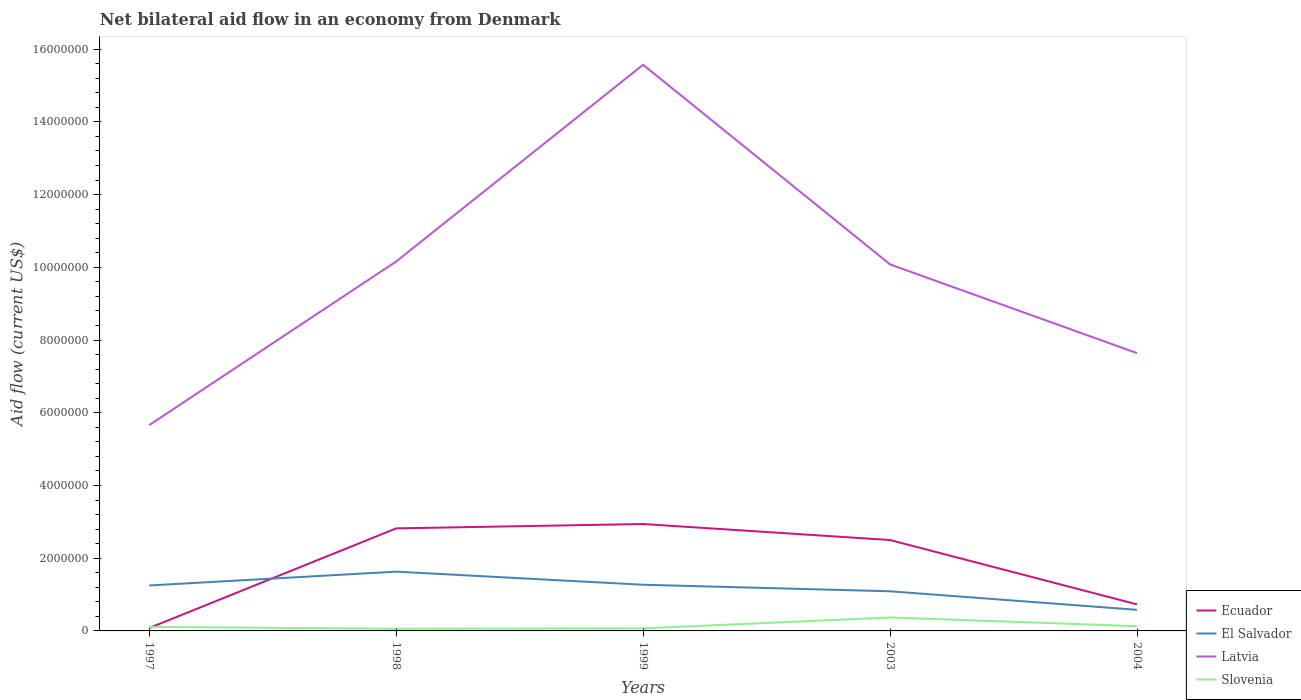Does the line corresponding to Ecuador intersect with the line corresponding to Latvia?
Keep it short and to the point. No. Is the number of lines equal to the number of legend labels?
Your answer should be very brief. Yes. Across all years, what is the maximum net bilateral aid flow in El Salvador?
Ensure brevity in your answer.  5.80e+05. In which year was the net bilateral aid flow in Latvia maximum?
Make the answer very short. 1997. What is the total net bilateral aid flow in Ecuador in the graph?
Give a very brief answer. -6.50e+05. What is the difference between the highest and the second highest net bilateral aid flow in Slovenia?
Your answer should be very brief. 3.10e+05. What is the difference between the highest and the lowest net bilateral aid flow in El Salvador?
Offer a very short reply. 3. Is the net bilateral aid flow in Latvia strictly greater than the net bilateral aid flow in Slovenia over the years?
Ensure brevity in your answer.  No. How many lines are there?
Offer a very short reply. 4. Does the graph contain any zero values?
Give a very brief answer. No. Does the graph contain grids?
Your answer should be compact. No. What is the title of the graph?
Your answer should be very brief. Net bilateral aid flow in an economy from Denmark. Does "Sao Tome and Principe" appear as one of the legend labels in the graph?
Your answer should be compact. No. What is the Aid flow (current US$) in El Salvador in 1997?
Provide a succinct answer. 1.25e+06. What is the Aid flow (current US$) of Latvia in 1997?
Ensure brevity in your answer.  5.66e+06. What is the Aid flow (current US$) in Slovenia in 1997?
Offer a very short reply. 1.10e+05. What is the Aid flow (current US$) of Ecuador in 1998?
Keep it short and to the point. 2.82e+06. What is the Aid flow (current US$) of El Salvador in 1998?
Keep it short and to the point. 1.63e+06. What is the Aid flow (current US$) in Latvia in 1998?
Keep it short and to the point. 1.02e+07. What is the Aid flow (current US$) of Ecuador in 1999?
Give a very brief answer. 2.94e+06. What is the Aid flow (current US$) of El Salvador in 1999?
Give a very brief answer. 1.27e+06. What is the Aid flow (current US$) in Latvia in 1999?
Make the answer very short. 1.56e+07. What is the Aid flow (current US$) of Slovenia in 1999?
Your response must be concise. 7.00e+04. What is the Aid flow (current US$) of Ecuador in 2003?
Offer a terse response. 2.50e+06. What is the Aid flow (current US$) of El Salvador in 2003?
Your response must be concise. 1.09e+06. What is the Aid flow (current US$) in Latvia in 2003?
Make the answer very short. 1.01e+07. What is the Aid flow (current US$) in Ecuador in 2004?
Your answer should be compact. 7.30e+05. What is the Aid flow (current US$) of El Salvador in 2004?
Provide a succinct answer. 5.80e+05. What is the Aid flow (current US$) in Latvia in 2004?
Give a very brief answer. 7.64e+06. What is the Aid flow (current US$) of Slovenia in 2004?
Offer a terse response. 1.30e+05. Across all years, what is the maximum Aid flow (current US$) in Ecuador?
Offer a very short reply. 2.94e+06. Across all years, what is the maximum Aid flow (current US$) of El Salvador?
Your answer should be very brief. 1.63e+06. Across all years, what is the maximum Aid flow (current US$) of Latvia?
Offer a terse response. 1.56e+07. Across all years, what is the minimum Aid flow (current US$) of Ecuador?
Offer a very short reply. 8.00e+04. Across all years, what is the minimum Aid flow (current US$) in El Salvador?
Provide a succinct answer. 5.80e+05. Across all years, what is the minimum Aid flow (current US$) in Latvia?
Offer a very short reply. 5.66e+06. Across all years, what is the minimum Aid flow (current US$) of Slovenia?
Give a very brief answer. 6.00e+04. What is the total Aid flow (current US$) in Ecuador in the graph?
Make the answer very short. 9.07e+06. What is the total Aid flow (current US$) in El Salvador in the graph?
Ensure brevity in your answer.  5.82e+06. What is the total Aid flow (current US$) in Latvia in the graph?
Offer a terse response. 4.91e+07. What is the total Aid flow (current US$) in Slovenia in the graph?
Your answer should be very brief. 7.40e+05. What is the difference between the Aid flow (current US$) of Ecuador in 1997 and that in 1998?
Keep it short and to the point. -2.74e+06. What is the difference between the Aid flow (current US$) in El Salvador in 1997 and that in 1998?
Offer a very short reply. -3.80e+05. What is the difference between the Aid flow (current US$) of Latvia in 1997 and that in 1998?
Provide a succinct answer. -4.50e+06. What is the difference between the Aid flow (current US$) of Ecuador in 1997 and that in 1999?
Give a very brief answer. -2.86e+06. What is the difference between the Aid flow (current US$) of Latvia in 1997 and that in 1999?
Your response must be concise. -9.91e+06. What is the difference between the Aid flow (current US$) in Slovenia in 1997 and that in 1999?
Offer a terse response. 4.00e+04. What is the difference between the Aid flow (current US$) of Ecuador in 1997 and that in 2003?
Offer a terse response. -2.42e+06. What is the difference between the Aid flow (current US$) in Latvia in 1997 and that in 2003?
Keep it short and to the point. -4.42e+06. What is the difference between the Aid flow (current US$) of Ecuador in 1997 and that in 2004?
Provide a succinct answer. -6.50e+05. What is the difference between the Aid flow (current US$) in El Salvador in 1997 and that in 2004?
Your response must be concise. 6.70e+05. What is the difference between the Aid flow (current US$) of Latvia in 1997 and that in 2004?
Provide a short and direct response. -1.98e+06. What is the difference between the Aid flow (current US$) in Ecuador in 1998 and that in 1999?
Provide a short and direct response. -1.20e+05. What is the difference between the Aid flow (current US$) of El Salvador in 1998 and that in 1999?
Ensure brevity in your answer.  3.60e+05. What is the difference between the Aid flow (current US$) in Latvia in 1998 and that in 1999?
Your answer should be very brief. -5.41e+06. What is the difference between the Aid flow (current US$) in Ecuador in 1998 and that in 2003?
Make the answer very short. 3.20e+05. What is the difference between the Aid flow (current US$) of El Salvador in 1998 and that in 2003?
Offer a very short reply. 5.40e+05. What is the difference between the Aid flow (current US$) of Latvia in 1998 and that in 2003?
Make the answer very short. 8.00e+04. What is the difference between the Aid flow (current US$) of Slovenia in 1998 and that in 2003?
Offer a terse response. -3.10e+05. What is the difference between the Aid flow (current US$) of Ecuador in 1998 and that in 2004?
Make the answer very short. 2.09e+06. What is the difference between the Aid flow (current US$) in El Salvador in 1998 and that in 2004?
Your answer should be very brief. 1.05e+06. What is the difference between the Aid flow (current US$) of Latvia in 1998 and that in 2004?
Your answer should be compact. 2.52e+06. What is the difference between the Aid flow (current US$) of Ecuador in 1999 and that in 2003?
Give a very brief answer. 4.40e+05. What is the difference between the Aid flow (current US$) of El Salvador in 1999 and that in 2003?
Your answer should be very brief. 1.80e+05. What is the difference between the Aid flow (current US$) of Latvia in 1999 and that in 2003?
Ensure brevity in your answer.  5.49e+06. What is the difference between the Aid flow (current US$) in Slovenia in 1999 and that in 2003?
Offer a terse response. -3.00e+05. What is the difference between the Aid flow (current US$) of Ecuador in 1999 and that in 2004?
Offer a terse response. 2.21e+06. What is the difference between the Aid flow (current US$) of El Salvador in 1999 and that in 2004?
Make the answer very short. 6.90e+05. What is the difference between the Aid flow (current US$) of Latvia in 1999 and that in 2004?
Keep it short and to the point. 7.93e+06. What is the difference between the Aid flow (current US$) in Slovenia in 1999 and that in 2004?
Offer a very short reply. -6.00e+04. What is the difference between the Aid flow (current US$) of Ecuador in 2003 and that in 2004?
Ensure brevity in your answer.  1.77e+06. What is the difference between the Aid flow (current US$) of El Salvador in 2003 and that in 2004?
Provide a short and direct response. 5.10e+05. What is the difference between the Aid flow (current US$) in Latvia in 2003 and that in 2004?
Your response must be concise. 2.44e+06. What is the difference between the Aid flow (current US$) of Ecuador in 1997 and the Aid flow (current US$) of El Salvador in 1998?
Your answer should be very brief. -1.55e+06. What is the difference between the Aid flow (current US$) of Ecuador in 1997 and the Aid flow (current US$) of Latvia in 1998?
Your answer should be compact. -1.01e+07. What is the difference between the Aid flow (current US$) in El Salvador in 1997 and the Aid flow (current US$) in Latvia in 1998?
Your answer should be compact. -8.91e+06. What is the difference between the Aid flow (current US$) in El Salvador in 1997 and the Aid flow (current US$) in Slovenia in 1998?
Offer a very short reply. 1.19e+06. What is the difference between the Aid flow (current US$) of Latvia in 1997 and the Aid flow (current US$) of Slovenia in 1998?
Provide a succinct answer. 5.60e+06. What is the difference between the Aid flow (current US$) in Ecuador in 1997 and the Aid flow (current US$) in El Salvador in 1999?
Offer a very short reply. -1.19e+06. What is the difference between the Aid flow (current US$) in Ecuador in 1997 and the Aid flow (current US$) in Latvia in 1999?
Ensure brevity in your answer.  -1.55e+07. What is the difference between the Aid flow (current US$) of El Salvador in 1997 and the Aid flow (current US$) of Latvia in 1999?
Make the answer very short. -1.43e+07. What is the difference between the Aid flow (current US$) in El Salvador in 1997 and the Aid flow (current US$) in Slovenia in 1999?
Make the answer very short. 1.18e+06. What is the difference between the Aid flow (current US$) of Latvia in 1997 and the Aid flow (current US$) of Slovenia in 1999?
Your answer should be very brief. 5.59e+06. What is the difference between the Aid flow (current US$) of Ecuador in 1997 and the Aid flow (current US$) of El Salvador in 2003?
Offer a very short reply. -1.01e+06. What is the difference between the Aid flow (current US$) of Ecuador in 1997 and the Aid flow (current US$) of Latvia in 2003?
Provide a succinct answer. -1.00e+07. What is the difference between the Aid flow (current US$) in Ecuador in 1997 and the Aid flow (current US$) in Slovenia in 2003?
Your response must be concise. -2.90e+05. What is the difference between the Aid flow (current US$) of El Salvador in 1997 and the Aid flow (current US$) of Latvia in 2003?
Make the answer very short. -8.83e+06. What is the difference between the Aid flow (current US$) of El Salvador in 1997 and the Aid flow (current US$) of Slovenia in 2003?
Make the answer very short. 8.80e+05. What is the difference between the Aid flow (current US$) in Latvia in 1997 and the Aid flow (current US$) in Slovenia in 2003?
Offer a very short reply. 5.29e+06. What is the difference between the Aid flow (current US$) of Ecuador in 1997 and the Aid flow (current US$) of El Salvador in 2004?
Make the answer very short. -5.00e+05. What is the difference between the Aid flow (current US$) in Ecuador in 1997 and the Aid flow (current US$) in Latvia in 2004?
Provide a short and direct response. -7.56e+06. What is the difference between the Aid flow (current US$) of El Salvador in 1997 and the Aid flow (current US$) of Latvia in 2004?
Provide a short and direct response. -6.39e+06. What is the difference between the Aid flow (current US$) of El Salvador in 1997 and the Aid flow (current US$) of Slovenia in 2004?
Provide a short and direct response. 1.12e+06. What is the difference between the Aid flow (current US$) in Latvia in 1997 and the Aid flow (current US$) in Slovenia in 2004?
Your answer should be very brief. 5.53e+06. What is the difference between the Aid flow (current US$) of Ecuador in 1998 and the Aid flow (current US$) of El Salvador in 1999?
Provide a short and direct response. 1.55e+06. What is the difference between the Aid flow (current US$) of Ecuador in 1998 and the Aid flow (current US$) of Latvia in 1999?
Keep it short and to the point. -1.28e+07. What is the difference between the Aid flow (current US$) of Ecuador in 1998 and the Aid flow (current US$) of Slovenia in 1999?
Keep it short and to the point. 2.75e+06. What is the difference between the Aid flow (current US$) in El Salvador in 1998 and the Aid flow (current US$) in Latvia in 1999?
Ensure brevity in your answer.  -1.39e+07. What is the difference between the Aid flow (current US$) in El Salvador in 1998 and the Aid flow (current US$) in Slovenia in 1999?
Provide a succinct answer. 1.56e+06. What is the difference between the Aid flow (current US$) of Latvia in 1998 and the Aid flow (current US$) of Slovenia in 1999?
Provide a succinct answer. 1.01e+07. What is the difference between the Aid flow (current US$) of Ecuador in 1998 and the Aid flow (current US$) of El Salvador in 2003?
Keep it short and to the point. 1.73e+06. What is the difference between the Aid flow (current US$) in Ecuador in 1998 and the Aid flow (current US$) in Latvia in 2003?
Ensure brevity in your answer.  -7.26e+06. What is the difference between the Aid flow (current US$) of Ecuador in 1998 and the Aid flow (current US$) of Slovenia in 2003?
Give a very brief answer. 2.45e+06. What is the difference between the Aid flow (current US$) in El Salvador in 1998 and the Aid flow (current US$) in Latvia in 2003?
Ensure brevity in your answer.  -8.45e+06. What is the difference between the Aid flow (current US$) of El Salvador in 1998 and the Aid flow (current US$) of Slovenia in 2003?
Your response must be concise. 1.26e+06. What is the difference between the Aid flow (current US$) in Latvia in 1998 and the Aid flow (current US$) in Slovenia in 2003?
Offer a very short reply. 9.79e+06. What is the difference between the Aid flow (current US$) in Ecuador in 1998 and the Aid flow (current US$) in El Salvador in 2004?
Offer a terse response. 2.24e+06. What is the difference between the Aid flow (current US$) in Ecuador in 1998 and the Aid flow (current US$) in Latvia in 2004?
Give a very brief answer. -4.82e+06. What is the difference between the Aid flow (current US$) in Ecuador in 1998 and the Aid flow (current US$) in Slovenia in 2004?
Provide a succinct answer. 2.69e+06. What is the difference between the Aid flow (current US$) of El Salvador in 1998 and the Aid flow (current US$) of Latvia in 2004?
Ensure brevity in your answer.  -6.01e+06. What is the difference between the Aid flow (current US$) of El Salvador in 1998 and the Aid flow (current US$) of Slovenia in 2004?
Provide a short and direct response. 1.50e+06. What is the difference between the Aid flow (current US$) in Latvia in 1998 and the Aid flow (current US$) in Slovenia in 2004?
Ensure brevity in your answer.  1.00e+07. What is the difference between the Aid flow (current US$) in Ecuador in 1999 and the Aid flow (current US$) in El Salvador in 2003?
Your answer should be very brief. 1.85e+06. What is the difference between the Aid flow (current US$) in Ecuador in 1999 and the Aid flow (current US$) in Latvia in 2003?
Give a very brief answer. -7.14e+06. What is the difference between the Aid flow (current US$) in Ecuador in 1999 and the Aid flow (current US$) in Slovenia in 2003?
Your response must be concise. 2.57e+06. What is the difference between the Aid flow (current US$) in El Salvador in 1999 and the Aid flow (current US$) in Latvia in 2003?
Provide a succinct answer. -8.81e+06. What is the difference between the Aid flow (current US$) of El Salvador in 1999 and the Aid flow (current US$) of Slovenia in 2003?
Offer a very short reply. 9.00e+05. What is the difference between the Aid flow (current US$) of Latvia in 1999 and the Aid flow (current US$) of Slovenia in 2003?
Offer a very short reply. 1.52e+07. What is the difference between the Aid flow (current US$) of Ecuador in 1999 and the Aid flow (current US$) of El Salvador in 2004?
Provide a succinct answer. 2.36e+06. What is the difference between the Aid flow (current US$) of Ecuador in 1999 and the Aid flow (current US$) of Latvia in 2004?
Your response must be concise. -4.70e+06. What is the difference between the Aid flow (current US$) in Ecuador in 1999 and the Aid flow (current US$) in Slovenia in 2004?
Keep it short and to the point. 2.81e+06. What is the difference between the Aid flow (current US$) in El Salvador in 1999 and the Aid flow (current US$) in Latvia in 2004?
Give a very brief answer. -6.37e+06. What is the difference between the Aid flow (current US$) in El Salvador in 1999 and the Aid flow (current US$) in Slovenia in 2004?
Your answer should be compact. 1.14e+06. What is the difference between the Aid flow (current US$) in Latvia in 1999 and the Aid flow (current US$) in Slovenia in 2004?
Provide a succinct answer. 1.54e+07. What is the difference between the Aid flow (current US$) in Ecuador in 2003 and the Aid flow (current US$) in El Salvador in 2004?
Your response must be concise. 1.92e+06. What is the difference between the Aid flow (current US$) of Ecuador in 2003 and the Aid flow (current US$) of Latvia in 2004?
Your answer should be very brief. -5.14e+06. What is the difference between the Aid flow (current US$) in Ecuador in 2003 and the Aid flow (current US$) in Slovenia in 2004?
Make the answer very short. 2.37e+06. What is the difference between the Aid flow (current US$) of El Salvador in 2003 and the Aid flow (current US$) of Latvia in 2004?
Provide a succinct answer. -6.55e+06. What is the difference between the Aid flow (current US$) of El Salvador in 2003 and the Aid flow (current US$) of Slovenia in 2004?
Ensure brevity in your answer.  9.60e+05. What is the difference between the Aid flow (current US$) of Latvia in 2003 and the Aid flow (current US$) of Slovenia in 2004?
Your response must be concise. 9.95e+06. What is the average Aid flow (current US$) of Ecuador per year?
Ensure brevity in your answer.  1.81e+06. What is the average Aid flow (current US$) in El Salvador per year?
Ensure brevity in your answer.  1.16e+06. What is the average Aid flow (current US$) of Latvia per year?
Offer a terse response. 9.82e+06. What is the average Aid flow (current US$) in Slovenia per year?
Provide a succinct answer. 1.48e+05. In the year 1997, what is the difference between the Aid flow (current US$) of Ecuador and Aid flow (current US$) of El Salvador?
Keep it short and to the point. -1.17e+06. In the year 1997, what is the difference between the Aid flow (current US$) of Ecuador and Aid flow (current US$) of Latvia?
Provide a short and direct response. -5.58e+06. In the year 1997, what is the difference between the Aid flow (current US$) of Ecuador and Aid flow (current US$) of Slovenia?
Your response must be concise. -3.00e+04. In the year 1997, what is the difference between the Aid flow (current US$) of El Salvador and Aid flow (current US$) of Latvia?
Offer a terse response. -4.41e+06. In the year 1997, what is the difference between the Aid flow (current US$) of El Salvador and Aid flow (current US$) of Slovenia?
Make the answer very short. 1.14e+06. In the year 1997, what is the difference between the Aid flow (current US$) in Latvia and Aid flow (current US$) in Slovenia?
Ensure brevity in your answer.  5.55e+06. In the year 1998, what is the difference between the Aid flow (current US$) of Ecuador and Aid flow (current US$) of El Salvador?
Your answer should be very brief. 1.19e+06. In the year 1998, what is the difference between the Aid flow (current US$) of Ecuador and Aid flow (current US$) of Latvia?
Provide a short and direct response. -7.34e+06. In the year 1998, what is the difference between the Aid flow (current US$) of Ecuador and Aid flow (current US$) of Slovenia?
Give a very brief answer. 2.76e+06. In the year 1998, what is the difference between the Aid flow (current US$) in El Salvador and Aid flow (current US$) in Latvia?
Make the answer very short. -8.53e+06. In the year 1998, what is the difference between the Aid flow (current US$) in El Salvador and Aid flow (current US$) in Slovenia?
Keep it short and to the point. 1.57e+06. In the year 1998, what is the difference between the Aid flow (current US$) in Latvia and Aid flow (current US$) in Slovenia?
Offer a terse response. 1.01e+07. In the year 1999, what is the difference between the Aid flow (current US$) of Ecuador and Aid flow (current US$) of El Salvador?
Offer a terse response. 1.67e+06. In the year 1999, what is the difference between the Aid flow (current US$) of Ecuador and Aid flow (current US$) of Latvia?
Your answer should be compact. -1.26e+07. In the year 1999, what is the difference between the Aid flow (current US$) of Ecuador and Aid flow (current US$) of Slovenia?
Give a very brief answer. 2.87e+06. In the year 1999, what is the difference between the Aid flow (current US$) in El Salvador and Aid flow (current US$) in Latvia?
Provide a short and direct response. -1.43e+07. In the year 1999, what is the difference between the Aid flow (current US$) of El Salvador and Aid flow (current US$) of Slovenia?
Provide a succinct answer. 1.20e+06. In the year 1999, what is the difference between the Aid flow (current US$) in Latvia and Aid flow (current US$) in Slovenia?
Your answer should be compact. 1.55e+07. In the year 2003, what is the difference between the Aid flow (current US$) in Ecuador and Aid flow (current US$) in El Salvador?
Your answer should be very brief. 1.41e+06. In the year 2003, what is the difference between the Aid flow (current US$) of Ecuador and Aid flow (current US$) of Latvia?
Provide a succinct answer. -7.58e+06. In the year 2003, what is the difference between the Aid flow (current US$) in Ecuador and Aid flow (current US$) in Slovenia?
Your response must be concise. 2.13e+06. In the year 2003, what is the difference between the Aid flow (current US$) in El Salvador and Aid flow (current US$) in Latvia?
Offer a very short reply. -8.99e+06. In the year 2003, what is the difference between the Aid flow (current US$) in El Salvador and Aid flow (current US$) in Slovenia?
Give a very brief answer. 7.20e+05. In the year 2003, what is the difference between the Aid flow (current US$) of Latvia and Aid flow (current US$) of Slovenia?
Keep it short and to the point. 9.71e+06. In the year 2004, what is the difference between the Aid flow (current US$) of Ecuador and Aid flow (current US$) of Latvia?
Your answer should be very brief. -6.91e+06. In the year 2004, what is the difference between the Aid flow (current US$) of Ecuador and Aid flow (current US$) of Slovenia?
Your answer should be very brief. 6.00e+05. In the year 2004, what is the difference between the Aid flow (current US$) of El Salvador and Aid flow (current US$) of Latvia?
Your answer should be very brief. -7.06e+06. In the year 2004, what is the difference between the Aid flow (current US$) of Latvia and Aid flow (current US$) of Slovenia?
Provide a succinct answer. 7.51e+06. What is the ratio of the Aid flow (current US$) in Ecuador in 1997 to that in 1998?
Offer a very short reply. 0.03. What is the ratio of the Aid flow (current US$) of El Salvador in 1997 to that in 1998?
Offer a terse response. 0.77. What is the ratio of the Aid flow (current US$) in Latvia in 1997 to that in 1998?
Offer a terse response. 0.56. What is the ratio of the Aid flow (current US$) of Slovenia in 1997 to that in 1998?
Provide a succinct answer. 1.83. What is the ratio of the Aid flow (current US$) of Ecuador in 1997 to that in 1999?
Your response must be concise. 0.03. What is the ratio of the Aid flow (current US$) of El Salvador in 1997 to that in 1999?
Make the answer very short. 0.98. What is the ratio of the Aid flow (current US$) in Latvia in 1997 to that in 1999?
Your response must be concise. 0.36. What is the ratio of the Aid flow (current US$) of Slovenia in 1997 to that in 1999?
Give a very brief answer. 1.57. What is the ratio of the Aid flow (current US$) in Ecuador in 1997 to that in 2003?
Offer a terse response. 0.03. What is the ratio of the Aid flow (current US$) of El Salvador in 1997 to that in 2003?
Give a very brief answer. 1.15. What is the ratio of the Aid flow (current US$) of Latvia in 1997 to that in 2003?
Your response must be concise. 0.56. What is the ratio of the Aid flow (current US$) in Slovenia in 1997 to that in 2003?
Your answer should be very brief. 0.3. What is the ratio of the Aid flow (current US$) of Ecuador in 1997 to that in 2004?
Keep it short and to the point. 0.11. What is the ratio of the Aid flow (current US$) in El Salvador in 1997 to that in 2004?
Ensure brevity in your answer.  2.16. What is the ratio of the Aid flow (current US$) in Latvia in 1997 to that in 2004?
Offer a very short reply. 0.74. What is the ratio of the Aid flow (current US$) of Slovenia in 1997 to that in 2004?
Your answer should be compact. 0.85. What is the ratio of the Aid flow (current US$) of Ecuador in 1998 to that in 1999?
Your answer should be compact. 0.96. What is the ratio of the Aid flow (current US$) of El Salvador in 1998 to that in 1999?
Provide a short and direct response. 1.28. What is the ratio of the Aid flow (current US$) in Latvia in 1998 to that in 1999?
Make the answer very short. 0.65. What is the ratio of the Aid flow (current US$) in Ecuador in 1998 to that in 2003?
Keep it short and to the point. 1.13. What is the ratio of the Aid flow (current US$) of El Salvador in 1998 to that in 2003?
Offer a terse response. 1.5. What is the ratio of the Aid flow (current US$) of Latvia in 1998 to that in 2003?
Offer a terse response. 1.01. What is the ratio of the Aid flow (current US$) in Slovenia in 1998 to that in 2003?
Keep it short and to the point. 0.16. What is the ratio of the Aid flow (current US$) of Ecuador in 1998 to that in 2004?
Give a very brief answer. 3.86. What is the ratio of the Aid flow (current US$) in El Salvador in 1998 to that in 2004?
Provide a succinct answer. 2.81. What is the ratio of the Aid flow (current US$) of Latvia in 1998 to that in 2004?
Make the answer very short. 1.33. What is the ratio of the Aid flow (current US$) of Slovenia in 1998 to that in 2004?
Make the answer very short. 0.46. What is the ratio of the Aid flow (current US$) in Ecuador in 1999 to that in 2003?
Provide a short and direct response. 1.18. What is the ratio of the Aid flow (current US$) in El Salvador in 1999 to that in 2003?
Provide a short and direct response. 1.17. What is the ratio of the Aid flow (current US$) in Latvia in 1999 to that in 2003?
Your answer should be very brief. 1.54. What is the ratio of the Aid flow (current US$) in Slovenia in 1999 to that in 2003?
Ensure brevity in your answer.  0.19. What is the ratio of the Aid flow (current US$) of Ecuador in 1999 to that in 2004?
Provide a short and direct response. 4.03. What is the ratio of the Aid flow (current US$) in El Salvador in 1999 to that in 2004?
Offer a very short reply. 2.19. What is the ratio of the Aid flow (current US$) in Latvia in 1999 to that in 2004?
Your answer should be compact. 2.04. What is the ratio of the Aid flow (current US$) in Slovenia in 1999 to that in 2004?
Give a very brief answer. 0.54. What is the ratio of the Aid flow (current US$) of Ecuador in 2003 to that in 2004?
Your answer should be very brief. 3.42. What is the ratio of the Aid flow (current US$) in El Salvador in 2003 to that in 2004?
Your answer should be very brief. 1.88. What is the ratio of the Aid flow (current US$) in Latvia in 2003 to that in 2004?
Your answer should be compact. 1.32. What is the ratio of the Aid flow (current US$) of Slovenia in 2003 to that in 2004?
Offer a terse response. 2.85. What is the difference between the highest and the second highest Aid flow (current US$) in Ecuador?
Give a very brief answer. 1.20e+05. What is the difference between the highest and the second highest Aid flow (current US$) in El Salvador?
Offer a very short reply. 3.60e+05. What is the difference between the highest and the second highest Aid flow (current US$) of Latvia?
Your answer should be compact. 5.41e+06. What is the difference between the highest and the lowest Aid flow (current US$) of Ecuador?
Give a very brief answer. 2.86e+06. What is the difference between the highest and the lowest Aid flow (current US$) of El Salvador?
Your response must be concise. 1.05e+06. What is the difference between the highest and the lowest Aid flow (current US$) of Latvia?
Keep it short and to the point. 9.91e+06. 